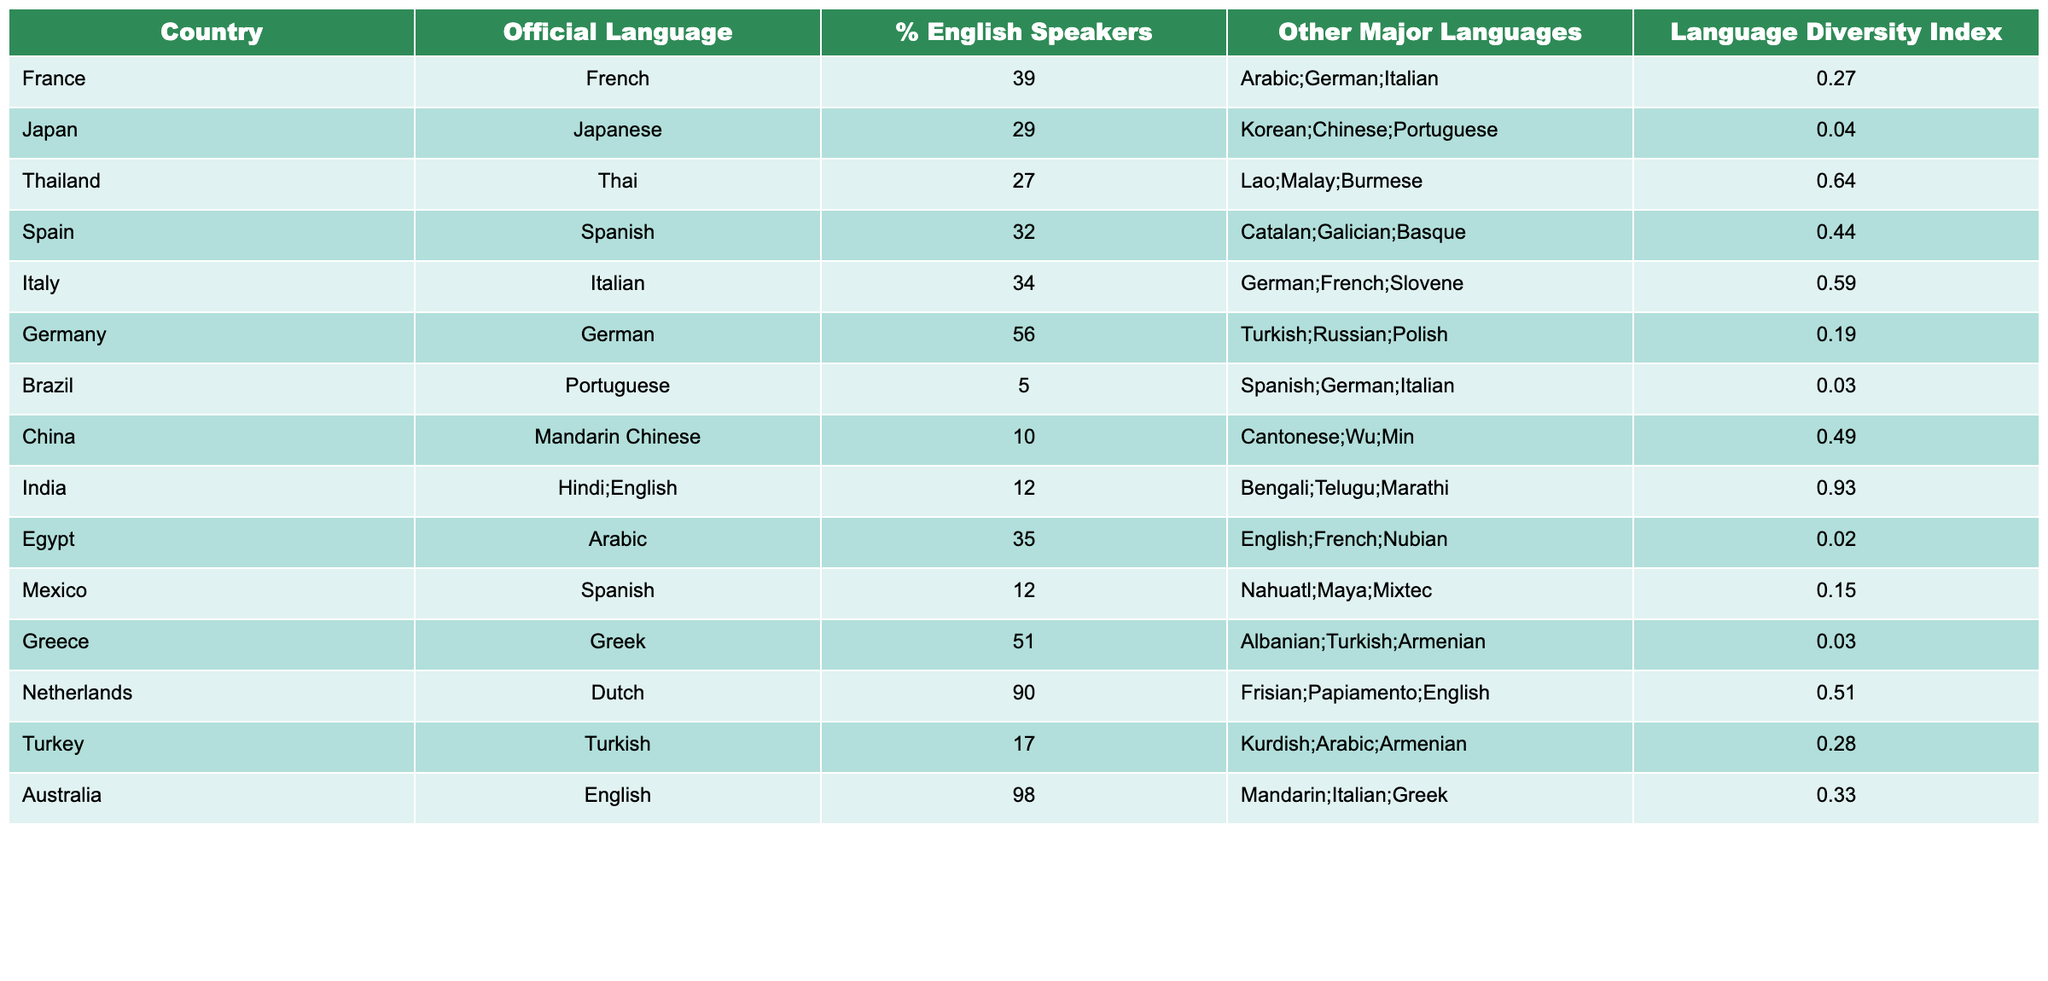What is the percentage of English speakers in Australia? The table shows that Australia has 98% English speakers listed under the "% English Speakers" column.
Answer: 98% Which country has the highest percentage of English speakers? According to the table, the highest percentage of English speakers is found in the Netherlands at 90%.
Answer: 90% What is the combined percentage of English speakers in Egypt and Japan? From the table, Egypt has 35% and Japan has 29% English speakers. Adding them together gives 35 + 29 = 64%.
Answer: 64% Is the Language Diversity Index higher in Thailand or in Italy? The Language Diversity Index for Thailand is 0.64 and for Italy is 0.59. Since 0.64 is greater than 0.59, Thailand has a higher index.
Answer: Yes, Thailand How many countries have more than 50% English speakers? The table shows two countries, the Netherlands with 90% and Australia with 98%, that exceed 50% English speakers.
Answer: 2 Which country has the lowest percentage of English speakers? The data indicates that Brazil has the lowest percentage at 5% of English speakers.
Answer: 5% What is the average percentage of English speakers among all listed countries? Adding the percentages of all countries (39 + 29 + 27 + 32 + 34 + 56 + 5 + 10 + 12 + 35 + 12 + 51 + 90 + 17 + 98 =  474) and dividing by 15 gives an average of 31.6%.
Answer: 31.6% Which country has the highest Language Diversity Index, and what is its value? The highest Language Diversity Index is in India, which has a value of 0.93 as shown in the table.
Answer: 0.93 Does Greece have more or less than 50% English speakers? The table shows that Greece has 51% English speakers. Since this is more than 50%, the answer is yes.
Answer: Yes Which two countries have nearly similar Language Diversity Index values, and what are those values? Thailand has 0.64 and Italy has 0.59. These values are close to each other indicating a similarity in language diversity.
Answer: Thailand 0.64, Italy 0.59 How many official languages does India have according to the table? The table states that India has two official languages: Hindi and English.
Answer: 2 